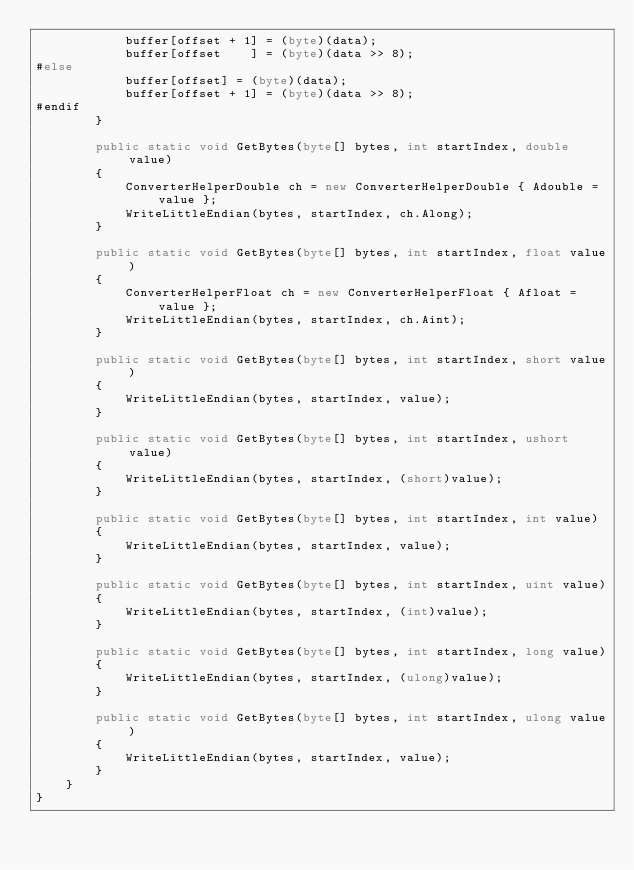<code> <loc_0><loc_0><loc_500><loc_500><_C#_>            buffer[offset + 1] = (byte)(data);
            buffer[offset    ] = (byte)(data >> 8);
#else
            buffer[offset] = (byte)(data);
            buffer[offset + 1] = (byte)(data >> 8);
#endif
        }

        public static void GetBytes(byte[] bytes, int startIndex, double value)
        {
            ConverterHelperDouble ch = new ConverterHelperDouble { Adouble = value };
            WriteLittleEndian(bytes, startIndex, ch.Along);
        }

        public static void GetBytes(byte[] bytes, int startIndex, float value)
        {
            ConverterHelperFloat ch = new ConverterHelperFloat { Afloat = value };
            WriteLittleEndian(bytes, startIndex, ch.Aint);
        }

        public static void GetBytes(byte[] bytes, int startIndex, short value)
        {
            WriteLittleEndian(bytes, startIndex, value);
        }

        public static void GetBytes(byte[] bytes, int startIndex, ushort value)
        {
            WriteLittleEndian(bytes, startIndex, (short)value);
        }

        public static void GetBytes(byte[] bytes, int startIndex, int value)
        {
            WriteLittleEndian(bytes, startIndex, value);
        }

        public static void GetBytes(byte[] bytes, int startIndex, uint value)
        {
            WriteLittleEndian(bytes, startIndex, (int)value);
        }

        public static void GetBytes(byte[] bytes, int startIndex, long value)
        {
            WriteLittleEndian(bytes, startIndex, (ulong)value);
        }

        public static void GetBytes(byte[] bytes, int startIndex, ulong value)
        {
            WriteLittleEndian(bytes, startIndex, value);
        }
    }
}
</code> 